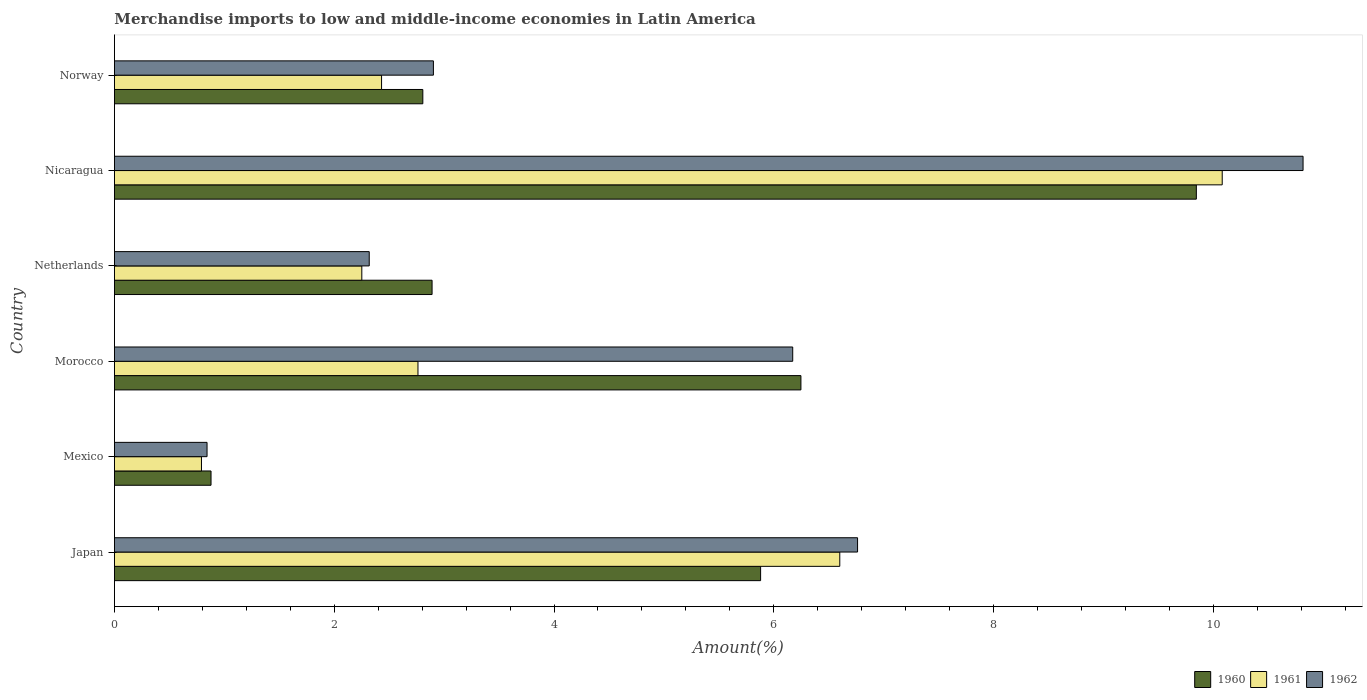How many groups of bars are there?
Make the answer very short. 6. Are the number of bars per tick equal to the number of legend labels?
Give a very brief answer. Yes. How many bars are there on the 6th tick from the top?
Your answer should be compact. 3. How many bars are there on the 2nd tick from the bottom?
Offer a terse response. 3. What is the percentage of amount earned from merchandise imports in 1962 in Mexico?
Keep it short and to the point. 0.84. Across all countries, what is the maximum percentage of amount earned from merchandise imports in 1961?
Provide a succinct answer. 10.08. Across all countries, what is the minimum percentage of amount earned from merchandise imports in 1960?
Your answer should be compact. 0.88. In which country was the percentage of amount earned from merchandise imports in 1962 maximum?
Give a very brief answer. Nicaragua. What is the total percentage of amount earned from merchandise imports in 1962 in the graph?
Give a very brief answer. 29.82. What is the difference between the percentage of amount earned from merchandise imports in 1960 in Japan and that in Nicaragua?
Your answer should be very brief. -3.97. What is the difference between the percentage of amount earned from merchandise imports in 1962 in Norway and the percentage of amount earned from merchandise imports in 1961 in Mexico?
Make the answer very short. 2.11. What is the average percentage of amount earned from merchandise imports in 1961 per country?
Ensure brevity in your answer.  4.15. What is the difference between the percentage of amount earned from merchandise imports in 1960 and percentage of amount earned from merchandise imports in 1961 in Morocco?
Make the answer very short. 3.48. What is the ratio of the percentage of amount earned from merchandise imports in 1962 in Morocco to that in Netherlands?
Ensure brevity in your answer.  2.66. Is the percentage of amount earned from merchandise imports in 1961 in Morocco less than that in Nicaragua?
Offer a terse response. Yes. What is the difference between the highest and the second highest percentage of amount earned from merchandise imports in 1962?
Your response must be concise. 4.05. What is the difference between the highest and the lowest percentage of amount earned from merchandise imports in 1961?
Make the answer very short. 9.29. What does the 3rd bar from the top in Morocco represents?
Make the answer very short. 1960. What does the 1st bar from the bottom in Mexico represents?
Your answer should be compact. 1960. Is it the case that in every country, the sum of the percentage of amount earned from merchandise imports in 1961 and percentage of amount earned from merchandise imports in 1960 is greater than the percentage of amount earned from merchandise imports in 1962?
Provide a succinct answer. Yes. How many bars are there?
Your answer should be very brief. 18. Are all the bars in the graph horizontal?
Provide a short and direct response. Yes. How many countries are there in the graph?
Ensure brevity in your answer.  6. Are the values on the major ticks of X-axis written in scientific E-notation?
Keep it short and to the point. No. How many legend labels are there?
Provide a succinct answer. 3. How are the legend labels stacked?
Provide a short and direct response. Horizontal. What is the title of the graph?
Your response must be concise. Merchandise imports to low and middle-income economies in Latin America. What is the label or title of the X-axis?
Keep it short and to the point. Amount(%). What is the Amount(%) in 1960 in Japan?
Give a very brief answer. 5.88. What is the Amount(%) in 1961 in Japan?
Offer a very short reply. 6.6. What is the Amount(%) in 1962 in Japan?
Your answer should be very brief. 6.76. What is the Amount(%) in 1960 in Mexico?
Provide a succinct answer. 0.88. What is the Amount(%) in 1961 in Mexico?
Ensure brevity in your answer.  0.79. What is the Amount(%) in 1962 in Mexico?
Make the answer very short. 0.84. What is the Amount(%) of 1960 in Morocco?
Your response must be concise. 6.25. What is the Amount(%) in 1961 in Morocco?
Make the answer very short. 2.76. What is the Amount(%) of 1962 in Morocco?
Offer a terse response. 6.17. What is the Amount(%) in 1960 in Netherlands?
Offer a terse response. 2.89. What is the Amount(%) in 1961 in Netherlands?
Offer a very short reply. 2.25. What is the Amount(%) of 1962 in Netherlands?
Your answer should be very brief. 2.32. What is the Amount(%) in 1960 in Nicaragua?
Your response must be concise. 9.85. What is the Amount(%) of 1961 in Nicaragua?
Make the answer very short. 10.08. What is the Amount(%) in 1962 in Nicaragua?
Make the answer very short. 10.82. What is the Amount(%) in 1960 in Norway?
Your response must be concise. 2.81. What is the Amount(%) of 1961 in Norway?
Offer a very short reply. 2.43. What is the Amount(%) in 1962 in Norway?
Provide a succinct answer. 2.9. Across all countries, what is the maximum Amount(%) of 1960?
Offer a terse response. 9.85. Across all countries, what is the maximum Amount(%) in 1961?
Offer a very short reply. 10.08. Across all countries, what is the maximum Amount(%) of 1962?
Ensure brevity in your answer.  10.82. Across all countries, what is the minimum Amount(%) in 1960?
Offer a very short reply. 0.88. Across all countries, what is the minimum Amount(%) of 1961?
Your answer should be compact. 0.79. Across all countries, what is the minimum Amount(%) in 1962?
Your answer should be very brief. 0.84. What is the total Amount(%) in 1960 in the graph?
Ensure brevity in your answer.  28.55. What is the total Amount(%) of 1961 in the graph?
Your answer should be compact. 24.92. What is the total Amount(%) of 1962 in the graph?
Make the answer very short. 29.82. What is the difference between the Amount(%) in 1960 in Japan and that in Mexico?
Your answer should be very brief. 5. What is the difference between the Amount(%) of 1961 in Japan and that in Mexico?
Your response must be concise. 5.81. What is the difference between the Amount(%) of 1962 in Japan and that in Mexico?
Your answer should be compact. 5.92. What is the difference between the Amount(%) of 1960 in Japan and that in Morocco?
Offer a terse response. -0.37. What is the difference between the Amount(%) in 1961 in Japan and that in Morocco?
Ensure brevity in your answer.  3.84. What is the difference between the Amount(%) of 1962 in Japan and that in Morocco?
Your response must be concise. 0.59. What is the difference between the Amount(%) in 1960 in Japan and that in Netherlands?
Give a very brief answer. 2.99. What is the difference between the Amount(%) of 1961 in Japan and that in Netherlands?
Provide a short and direct response. 4.35. What is the difference between the Amount(%) of 1962 in Japan and that in Netherlands?
Your response must be concise. 4.44. What is the difference between the Amount(%) of 1960 in Japan and that in Nicaragua?
Offer a terse response. -3.97. What is the difference between the Amount(%) in 1961 in Japan and that in Nicaragua?
Offer a terse response. -3.48. What is the difference between the Amount(%) of 1962 in Japan and that in Nicaragua?
Provide a succinct answer. -4.05. What is the difference between the Amount(%) in 1960 in Japan and that in Norway?
Provide a short and direct response. 3.07. What is the difference between the Amount(%) of 1961 in Japan and that in Norway?
Give a very brief answer. 4.17. What is the difference between the Amount(%) in 1962 in Japan and that in Norway?
Give a very brief answer. 3.86. What is the difference between the Amount(%) in 1960 in Mexico and that in Morocco?
Offer a terse response. -5.37. What is the difference between the Amount(%) of 1961 in Mexico and that in Morocco?
Offer a very short reply. -1.97. What is the difference between the Amount(%) in 1962 in Mexico and that in Morocco?
Provide a short and direct response. -5.33. What is the difference between the Amount(%) of 1960 in Mexico and that in Netherlands?
Provide a short and direct response. -2.01. What is the difference between the Amount(%) in 1961 in Mexico and that in Netherlands?
Provide a short and direct response. -1.46. What is the difference between the Amount(%) in 1962 in Mexico and that in Netherlands?
Ensure brevity in your answer.  -1.48. What is the difference between the Amount(%) of 1960 in Mexico and that in Nicaragua?
Offer a very short reply. -8.97. What is the difference between the Amount(%) in 1961 in Mexico and that in Nicaragua?
Provide a succinct answer. -9.29. What is the difference between the Amount(%) in 1962 in Mexico and that in Nicaragua?
Offer a very short reply. -9.97. What is the difference between the Amount(%) in 1960 in Mexico and that in Norway?
Provide a short and direct response. -1.93. What is the difference between the Amount(%) of 1961 in Mexico and that in Norway?
Ensure brevity in your answer.  -1.64. What is the difference between the Amount(%) of 1962 in Mexico and that in Norway?
Your answer should be compact. -2.06. What is the difference between the Amount(%) in 1960 in Morocco and that in Netherlands?
Keep it short and to the point. 3.36. What is the difference between the Amount(%) in 1961 in Morocco and that in Netherlands?
Give a very brief answer. 0.51. What is the difference between the Amount(%) of 1962 in Morocco and that in Netherlands?
Give a very brief answer. 3.85. What is the difference between the Amount(%) in 1960 in Morocco and that in Nicaragua?
Make the answer very short. -3.6. What is the difference between the Amount(%) of 1961 in Morocco and that in Nicaragua?
Your response must be concise. -7.32. What is the difference between the Amount(%) in 1962 in Morocco and that in Nicaragua?
Make the answer very short. -4.64. What is the difference between the Amount(%) of 1960 in Morocco and that in Norway?
Ensure brevity in your answer.  3.44. What is the difference between the Amount(%) of 1961 in Morocco and that in Norway?
Make the answer very short. 0.33. What is the difference between the Amount(%) in 1962 in Morocco and that in Norway?
Make the answer very short. 3.27. What is the difference between the Amount(%) of 1960 in Netherlands and that in Nicaragua?
Your answer should be compact. -6.95. What is the difference between the Amount(%) of 1961 in Netherlands and that in Nicaragua?
Give a very brief answer. -7.83. What is the difference between the Amount(%) of 1962 in Netherlands and that in Nicaragua?
Provide a succinct answer. -8.5. What is the difference between the Amount(%) in 1960 in Netherlands and that in Norway?
Offer a very short reply. 0.08. What is the difference between the Amount(%) of 1961 in Netherlands and that in Norway?
Your answer should be very brief. -0.18. What is the difference between the Amount(%) of 1962 in Netherlands and that in Norway?
Offer a terse response. -0.58. What is the difference between the Amount(%) of 1960 in Nicaragua and that in Norway?
Give a very brief answer. 7.04. What is the difference between the Amount(%) of 1961 in Nicaragua and that in Norway?
Offer a terse response. 7.65. What is the difference between the Amount(%) of 1962 in Nicaragua and that in Norway?
Keep it short and to the point. 7.91. What is the difference between the Amount(%) in 1960 in Japan and the Amount(%) in 1961 in Mexico?
Give a very brief answer. 5.09. What is the difference between the Amount(%) in 1960 in Japan and the Amount(%) in 1962 in Mexico?
Your answer should be very brief. 5.04. What is the difference between the Amount(%) of 1961 in Japan and the Amount(%) of 1962 in Mexico?
Keep it short and to the point. 5.76. What is the difference between the Amount(%) in 1960 in Japan and the Amount(%) in 1961 in Morocco?
Offer a very short reply. 3.12. What is the difference between the Amount(%) of 1960 in Japan and the Amount(%) of 1962 in Morocco?
Give a very brief answer. -0.29. What is the difference between the Amount(%) in 1961 in Japan and the Amount(%) in 1962 in Morocco?
Offer a terse response. 0.43. What is the difference between the Amount(%) in 1960 in Japan and the Amount(%) in 1961 in Netherlands?
Your answer should be very brief. 3.63. What is the difference between the Amount(%) of 1960 in Japan and the Amount(%) of 1962 in Netherlands?
Keep it short and to the point. 3.56. What is the difference between the Amount(%) of 1961 in Japan and the Amount(%) of 1962 in Netherlands?
Your answer should be compact. 4.28. What is the difference between the Amount(%) of 1960 in Japan and the Amount(%) of 1961 in Nicaragua?
Your answer should be compact. -4.2. What is the difference between the Amount(%) of 1960 in Japan and the Amount(%) of 1962 in Nicaragua?
Your answer should be compact. -4.94. What is the difference between the Amount(%) in 1961 in Japan and the Amount(%) in 1962 in Nicaragua?
Your answer should be very brief. -4.22. What is the difference between the Amount(%) of 1960 in Japan and the Amount(%) of 1961 in Norway?
Make the answer very short. 3.45. What is the difference between the Amount(%) in 1960 in Japan and the Amount(%) in 1962 in Norway?
Provide a succinct answer. 2.98. What is the difference between the Amount(%) of 1961 in Japan and the Amount(%) of 1962 in Norway?
Offer a very short reply. 3.7. What is the difference between the Amount(%) of 1960 in Mexico and the Amount(%) of 1961 in Morocco?
Give a very brief answer. -1.88. What is the difference between the Amount(%) of 1960 in Mexico and the Amount(%) of 1962 in Morocco?
Offer a terse response. -5.29. What is the difference between the Amount(%) of 1961 in Mexico and the Amount(%) of 1962 in Morocco?
Keep it short and to the point. -5.38. What is the difference between the Amount(%) in 1960 in Mexico and the Amount(%) in 1961 in Netherlands?
Provide a short and direct response. -1.37. What is the difference between the Amount(%) of 1960 in Mexico and the Amount(%) of 1962 in Netherlands?
Provide a succinct answer. -1.44. What is the difference between the Amount(%) in 1961 in Mexico and the Amount(%) in 1962 in Netherlands?
Offer a terse response. -1.53. What is the difference between the Amount(%) in 1960 in Mexico and the Amount(%) in 1961 in Nicaragua?
Provide a succinct answer. -9.2. What is the difference between the Amount(%) in 1960 in Mexico and the Amount(%) in 1962 in Nicaragua?
Offer a very short reply. -9.94. What is the difference between the Amount(%) in 1961 in Mexico and the Amount(%) in 1962 in Nicaragua?
Keep it short and to the point. -10.02. What is the difference between the Amount(%) in 1960 in Mexico and the Amount(%) in 1961 in Norway?
Your answer should be very brief. -1.55. What is the difference between the Amount(%) in 1960 in Mexico and the Amount(%) in 1962 in Norway?
Provide a succinct answer. -2.02. What is the difference between the Amount(%) of 1961 in Mexico and the Amount(%) of 1962 in Norway?
Provide a succinct answer. -2.11. What is the difference between the Amount(%) in 1960 in Morocco and the Amount(%) in 1961 in Netherlands?
Give a very brief answer. 4. What is the difference between the Amount(%) in 1960 in Morocco and the Amount(%) in 1962 in Netherlands?
Offer a very short reply. 3.93. What is the difference between the Amount(%) in 1961 in Morocco and the Amount(%) in 1962 in Netherlands?
Your response must be concise. 0.44. What is the difference between the Amount(%) in 1960 in Morocco and the Amount(%) in 1961 in Nicaragua?
Your answer should be very brief. -3.83. What is the difference between the Amount(%) of 1960 in Morocco and the Amount(%) of 1962 in Nicaragua?
Give a very brief answer. -4.57. What is the difference between the Amount(%) in 1961 in Morocco and the Amount(%) in 1962 in Nicaragua?
Your response must be concise. -8.05. What is the difference between the Amount(%) of 1960 in Morocco and the Amount(%) of 1961 in Norway?
Keep it short and to the point. 3.82. What is the difference between the Amount(%) in 1960 in Morocco and the Amount(%) in 1962 in Norway?
Provide a short and direct response. 3.34. What is the difference between the Amount(%) of 1961 in Morocco and the Amount(%) of 1962 in Norway?
Your response must be concise. -0.14. What is the difference between the Amount(%) in 1960 in Netherlands and the Amount(%) in 1961 in Nicaragua?
Ensure brevity in your answer.  -7.19. What is the difference between the Amount(%) in 1960 in Netherlands and the Amount(%) in 1962 in Nicaragua?
Give a very brief answer. -7.93. What is the difference between the Amount(%) of 1961 in Netherlands and the Amount(%) of 1962 in Nicaragua?
Your response must be concise. -8.57. What is the difference between the Amount(%) of 1960 in Netherlands and the Amount(%) of 1961 in Norway?
Provide a short and direct response. 0.46. What is the difference between the Amount(%) in 1960 in Netherlands and the Amount(%) in 1962 in Norway?
Your response must be concise. -0.01. What is the difference between the Amount(%) in 1961 in Netherlands and the Amount(%) in 1962 in Norway?
Provide a short and direct response. -0.65. What is the difference between the Amount(%) in 1960 in Nicaragua and the Amount(%) in 1961 in Norway?
Ensure brevity in your answer.  7.41. What is the difference between the Amount(%) in 1960 in Nicaragua and the Amount(%) in 1962 in Norway?
Offer a terse response. 6.94. What is the difference between the Amount(%) of 1961 in Nicaragua and the Amount(%) of 1962 in Norway?
Your answer should be very brief. 7.18. What is the average Amount(%) of 1960 per country?
Offer a very short reply. 4.76. What is the average Amount(%) of 1961 per country?
Keep it short and to the point. 4.15. What is the average Amount(%) in 1962 per country?
Your response must be concise. 4.97. What is the difference between the Amount(%) in 1960 and Amount(%) in 1961 in Japan?
Keep it short and to the point. -0.72. What is the difference between the Amount(%) in 1960 and Amount(%) in 1962 in Japan?
Offer a very short reply. -0.88. What is the difference between the Amount(%) of 1961 and Amount(%) of 1962 in Japan?
Offer a very short reply. -0.16. What is the difference between the Amount(%) in 1960 and Amount(%) in 1961 in Mexico?
Your response must be concise. 0.09. What is the difference between the Amount(%) in 1960 and Amount(%) in 1962 in Mexico?
Your response must be concise. 0.04. What is the difference between the Amount(%) in 1961 and Amount(%) in 1962 in Mexico?
Make the answer very short. -0.05. What is the difference between the Amount(%) in 1960 and Amount(%) in 1961 in Morocco?
Make the answer very short. 3.48. What is the difference between the Amount(%) in 1960 and Amount(%) in 1962 in Morocco?
Your answer should be very brief. 0.07. What is the difference between the Amount(%) of 1961 and Amount(%) of 1962 in Morocco?
Your answer should be very brief. -3.41. What is the difference between the Amount(%) of 1960 and Amount(%) of 1961 in Netherlands?
Provide a succinct answer. 0.64. What is the difference between the Amount(%) in 1960 and Amount(%) in 1962 in Netherlands?
Your answer should be compact. 0.57. What is the difference between the Amount(%) of 1961 and Amount(%) of 1962 in Netherlands?
Your answer should be very brief. -0.07. What is the difference between the Amount(%) of 1960 and Amount(%) of 1961 in Nicaragua?
Your response must be concise. -0.24. What is the difference between the Amount(%) of 1960 and Amount(%) of 1962 in Nicaragua?
Keep it short and to the point. -0.97. What is the difference between the Amount(%) in 1961 and Amount(%) in 1962 in Nicaragua?
Offer a very short reply. -0.74. What is the difference between the Amount(%) of 1960 and Amount(%) of 1961 in Norway?
Provide a short and direct response. 0.38. What is the difference between the Amount(%) of 1960 and Amount(%) of 1962 in Norway?
Ensure brevity in your answer.  -0.1. What is the difference between the Amount(%) in 1961 and Amount(%) in 1962 in Norway?
Give a very brief answer. -0.47. What is the ratio of the Amount(%) in 1960 in Japan to that in Mexico?
Give a very brief answer. 6.69. What is the ratio of the Amount(%) of 1961 in Japan to that in Mexico?
Your answer should be very brief. 8.33. What is the ratio of the Amount(%) in 1962 in Japan to that in Mexico?
Provide a succinct answer. 8.02. What is the ratio of the Amount(%) in 1960 in Japan to that in Morocco?
Provide a succinct answer. 0.94. What is the ratio of the Amount(%) in 1961 in Japan to that in Morocco?
Provide a short and direct response. 2.39. What is the ratio of the Amount(%) in 1962 in Japan to that in Morocco?
Offer a very short reply. 1.1. What is the ratio of the Amount(%) of 1960 in Japan to that in Netherlands?
Offer a terse response. 2.03. What is the ratio of the Amount(%) in 1961 in Japan to that in Netherlands?
Your response must be concise. 2.93. What is the ratio of the Amount(%) of 1962 in Japan to that in Netherlands?
Give a very brief answer. 2.92. What is the ratio of the Amount(%) in 1960 in Japan to that in Nicaragua?
Make the answer very short. 0.6. What is the ratio of the Amount(%) in 1961 in Japan to that in Nicaragua?
Give a very brief answer. 0.65. What is the ratio of the Amount(%) of 1962 in Japan to that in Nicaragua?
Provide a short and direct response. 0.63. What is the ratio of the Amount(%) of 1960 in Japan to that in Norway?
Your response must be concise. 2.1. What is the ratio of the Amount(%) in 1961 in Japan to that in Norway?
Ensure brevity in your answer.  2.72. What is the ratio of the Amount(%) of 1962 in Japan to that in Norway?
Offer a terse response. 2.33. What is the ratio of the Amount(%) of 1960 in Mexico to that in Morocco?
Ensure brevity in your answer.  0.14. What is the ratio of the Amount(%) of 1961 in Mexico to that in Morocco?
Offer a terse response. 0.29. What is the ratio of the Amount(%) in 1962 in Mexico to that in Morocco?
Keep it short and to the point. 0.14. What is the ratio of the Amount(%) in 1960 in Mexico to that in Netherlands?
Ensure brevity in your answer.  0.3. What is the ratio of the Amount(%) in 1961 in Mexico to that in Netherlands?
Give a very brief answer. 0.35. What is the ratio of the Amount(%) of 1962 in Mexico to that in Netherlands?
Your answer should be compact. 0.36. What is the ratio of the Amount(%) of 1960 in Mexico to that in Nicaragua?
Ensure brevity in your answer.  0.09. What is the ratio of the Amount(%) in 1961 in Mexico to that in Nicaragua?
Provide a short and direct response. 0.08. What is the ratio of the Amount(%) in 1962 in Mexico to that in Nicaragua?
Your answer should be very brief. 0.08. What is the ratio of the Amount(%) of 1960 in Mexico to that in Norway?
Your response must be concise. 0.31. What is the ratio of the Amount(%) of 1961 in Mexico to that in Norway?
Keep it short and to the point. 0.33. What is the ratio of the Amount(%) of 1962 in Mexico to that in Norway?
Make the answer very short. 0.29. What is the ratio of the Amount(%) of 1960 in Morocco to that in Netherlands?
Provide a short and direct response. 2.16. What is the ratio of the Amount(%) in 1961 in Morocco to that in Netherlands?
Provide a succinct answer. 1.23. What is the ratio of the Amount(%) in 1962 in Morocco to that in Netherlands?
Your answer should be very brief. 2.66. What is the ratio of the Amount(%) in 1960 in Morocco to that in Nicaragua?
Provide a succinct answer. 0.63. What is the ratio of the Amount(%) in 1961 in Morocco to that in Nicaragua?
Provide a succinct answer. 0.27. What is the ratio of the Amount(%) in 1962 in Morocco to that in Nicaragua?
Your response must be concise. 0.57. What is the ratio of the Amount(%) in 1960 in Morocco to that in Norway?
Offer a very short reply. 2.23. What is the ratio of the Amount(%) in 1961 in Morocco to that in Norway?
Offer a terse response. 1.14. What is the ratio of the Amount(%) of 1962 in Morocco to that in Norway?
Offer a very short reply. 2.13. What is the ratio of the Amount(%) of 1960 in Netherlands to that in Nicaragua?
Provide a short and direct response. 0.29. What is the ratio of the Amount(%) in 1961 in Netherlands to that in Nicaragua?
Your answer should be very brief. 0.22. What is the ratio of the Amount(%) of 1962 in Netherlands to that in Nicaragua?
Make the answer very short. 0.21. What is the ratio of the Amount(%) in 1960 in Netherlands to that in Norway?
Offer a very short reply. 1.03. What is the ratio of the Amount(%) in 1961 in Netherlands to that in Norway?
Your answer should be very brief. 0.93. What is the ratio of the Amount(%) in 1962 in Netherlands to that in Norway?
Your response must be concise. 0.8. What is the ratio of the Amount(%) of 1960 in Nicaragua to that in Norway?
Give a very brief answer. 3.51. What is the ratio of the Amount(%) of 1961 in Nicaragua to that in Norway?
Provide a short and direct response. 4.15. What is the ratio of the Amount(%) in 1962 in Nicaragua to that in Norway?
Offer a very short reply. 3.73. What is the difference between the highest and the second highest Amount(%) of 1960?
Provide a short and direct response. 3.6. What is the difference between the highest and the second highest Amount(%) of 1961?
Ensure brevity in your answer.  3.48. What is the difference between the highest and the second highest Amount(%) of 1962?
Provide a succinct answer. 4.05. What is the difference between the highest and the lowest Amount(%) in 1960?
Provide a short and direct response. 8.97. What is the difference between the highest and the lowest Amount(%) of 1961?
Keep it short and to the point. 9.29. What is the difference between the highest and the lowest Amount(%) in 1962?
Offer a very short reply. 9.97. 